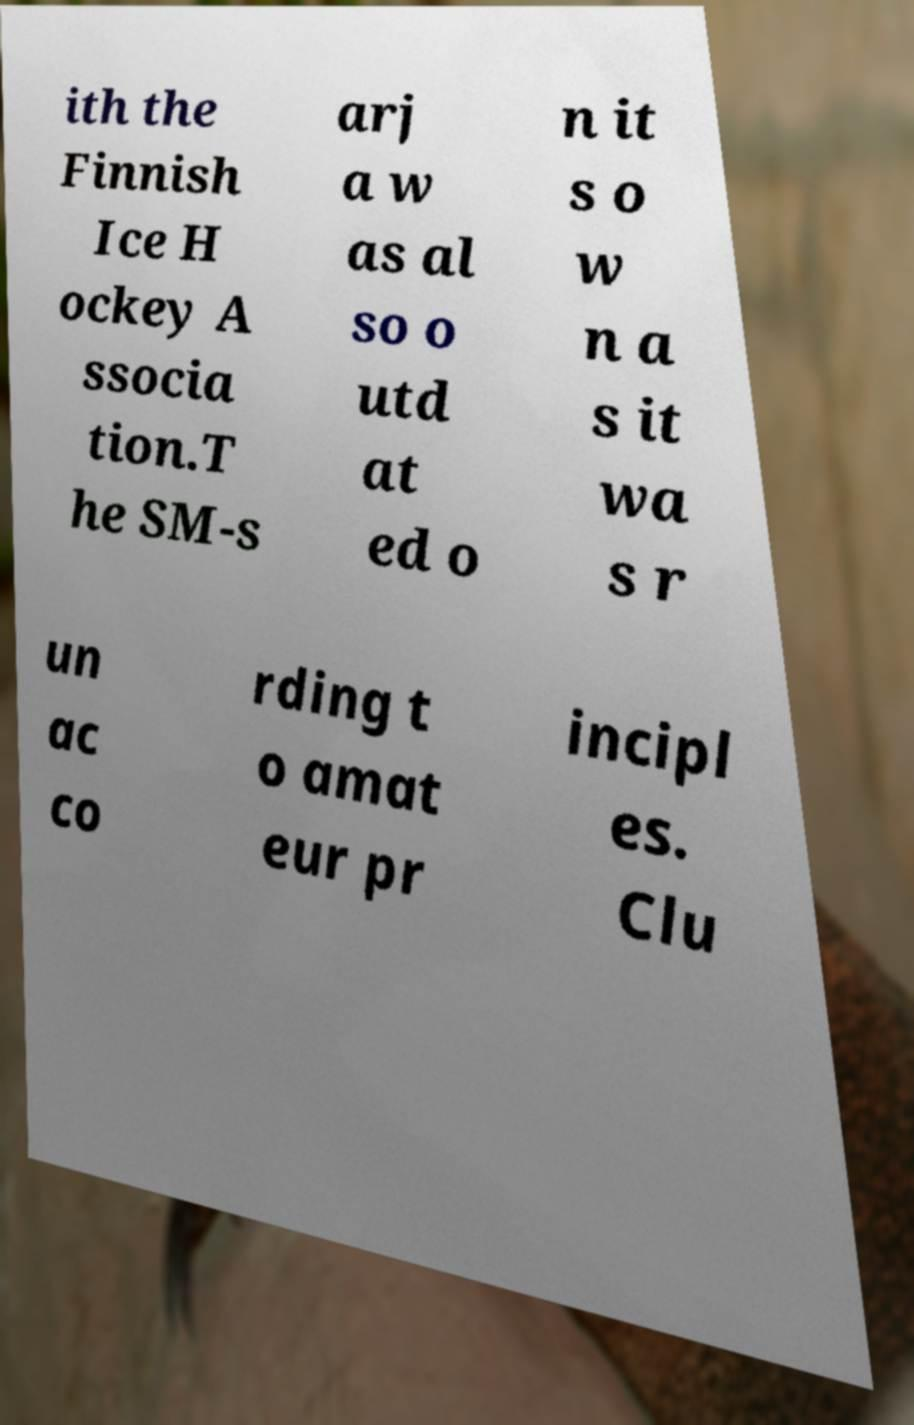Can you read and provide the text displayed in the image?This photo seems to have some interesting text. Can you extract and type it out for me? ith the Finnish Ice H ockey A ssocia tion.T he SM-s arj a w as al so o utd at ed o n it s o w n a s it wa s r un ac co rding t o amat eur pr incipl es. Clu 